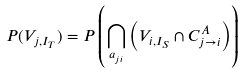<formula> <loc_0><loc_0><loc_500><loc_500>P ( V _ { j , I _ { T } } ) = P \left ( \bigcap _ { a _ { j i } } \left ( V _ { i , I _ { S } } \cap C ^ { A } _ { j \rightarrow i } \right ) \right )</formula> 